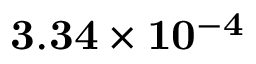Convert formula to latex. <formula><loc_0><loc_0><loc_500><loc_500>3 . 3 4 \times 1 0 ^ { - 4 }</formula> 